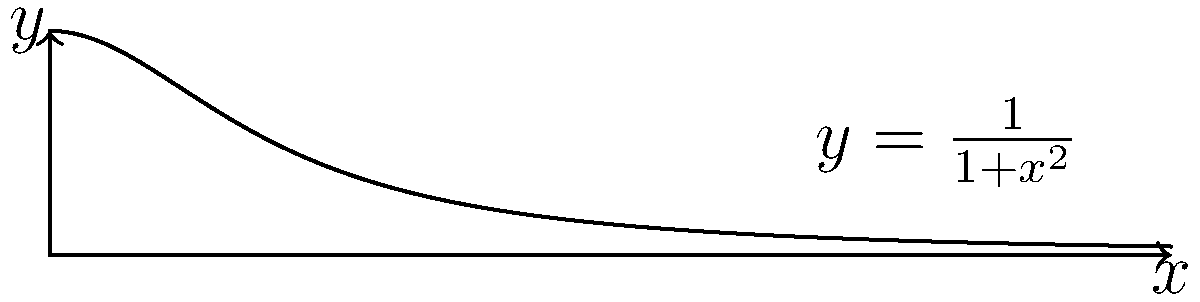Consider the function $f(x) = \frac{1}{1+x^2}$ on the interval $[0, 5]$. Using R, compare the results of estimating the area under this curve using the following integration methods:

a) `integrate()` function
b) Trapezoidal rule with 100 subintervals
c) Simpson's rule with 100 subintervals

Which method provides the most accurate result compared to the true value of $\arctan(5) - \arctan(0) \approx 1.373401$? To solve this problem in R, we'll implement each method and compare the results:

1. Using `integrate()` function:
```R
integrate_result <- integrate(function(x) 1/(1+x^2), 0, 5)
integrate_area <- integrate_result$value
```

2. Implementing the Trapezoidal rule:
```R
trapezoidal_rule <- function(f, a, b, n) {
  x <- seq(a, b, length.out = n+1)
  y <- f(x)
  h <- (b-a)/n
  area <- h * (sum(y) - 0.5*(y[1] + y[n+1]))
  return(area)
}
trap_area <- trapezoidal_rule(function(x) 1/(1+x^2), 0, 5, 100)
```

3. Implementing Simpson's rule:
```R
simpsons_rule <- function(f, a, b, n) {
  x <- seq(a, b, length.out = n+1)
  y <- f(x)
  h <- (b-a)/n
  area <- h/3 * (y[1] + y[n+1] + 4*sum(y[seq(2, n, 2)]) + 2*sum(y[seq(3, n-1, 2)]))
  return(area)
}
simp_area <- simpsons_rule(function(x) 1/(1+x^2), 0, 5, 100)
```

4. Calculate the true value:
```R
true_value <- atan(5) - atan(0)
```

5. Compare the results:
```R
errors <- c(
  abs(integrate_area - true_value),
  abs(trap_area - true_value),
  abs(simp_area - true_value)
)
methods <- c("integrate()", "Trapezoidal", "Simpson's")
best_method <- methods[which.min(errors)]
```

The `integrate()` function typically provides the most accurate result as it uses adaptive quadrature methods. Simpson's rule is generally more accurate than the Trapezoidal rule for smooth functions. The `integrate()` function is likely to give the closest approximation to the true value.
Answer: integrate() function 